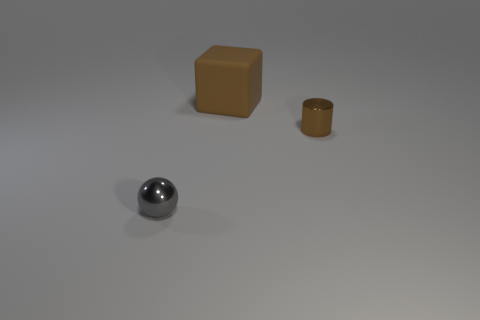There is a tiny shiny object behind the gray metal ball; how many big brown rubber blocks are behind it?
Provide a short and direct response. 1. How many things are small metallic things in front of the tiny brown object or brown metallic things?
Ensure brevity in your answer.  2. Is there a big brown thing of the same shape as the small brown thing?
Keep it short and to the point. No. There is a small metallic object that is left of the brown object in front of the brown rubber block; what shape is it?
Your response must be concise. Sphere. How many spheres are small objects or large blue rubber objects?
Your answer should be very brief. 1. There is a tiny cylinder that is the same color as the big rubber thing; what is its material?
Provide a succinct answer. Metal. Do the brown thing that is left of the tiny brown object and the brown object on the right side of the large brown rubber thing have the same shape?
Make the answer very short. No. There is a thing that is in front of the rubber object and behind the gray shiny thing; what color is it?
Offer a very short reply. Brown. Does the tiny metal cylinder have the same color as the big cube that is behind the tiny gray sphere?
Ensure brevity in your answer.  Yes. What size is the thing that is both behind the small gray metal sphere and in front of the large brown thing?
Provide a succinct answer. Small. 